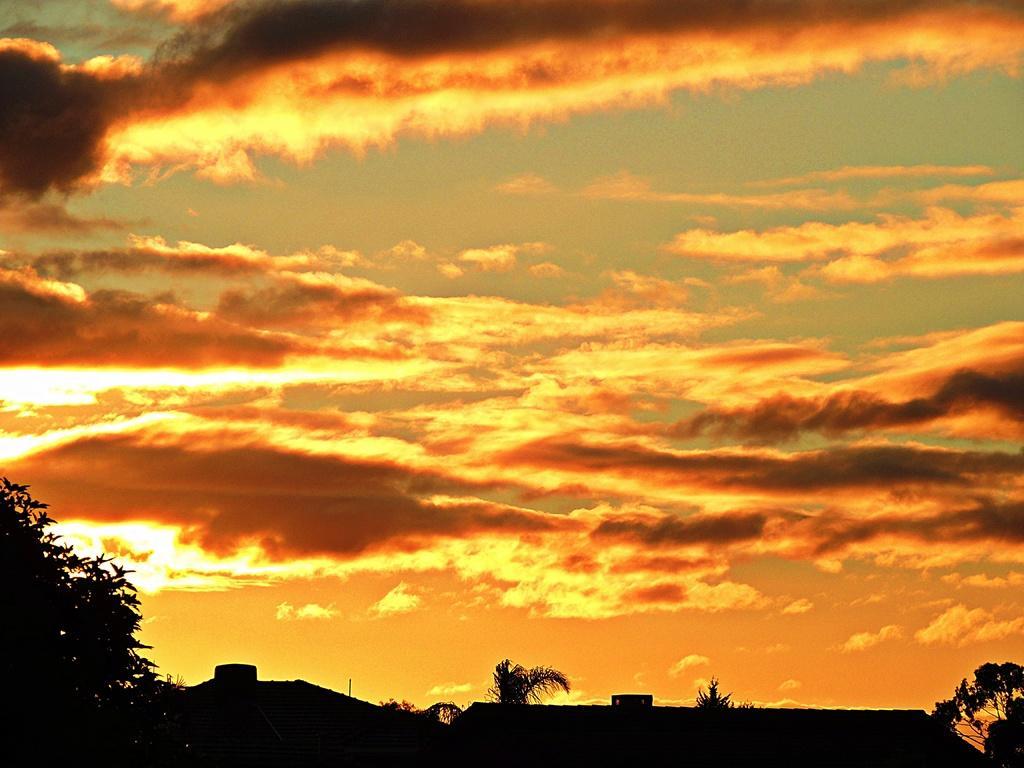Can you describe this image briefly? In this image I can see few trees. In the background the sky is in orange, yellow and gray color. 